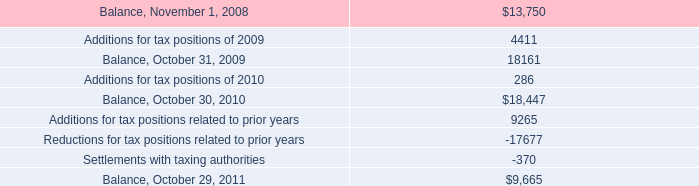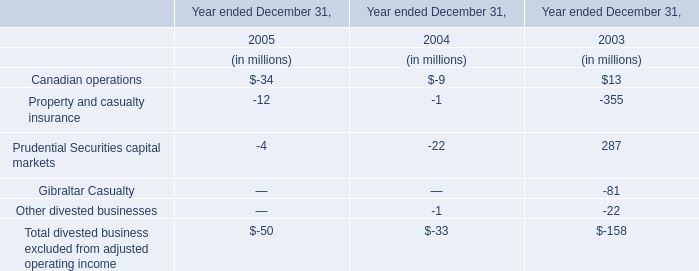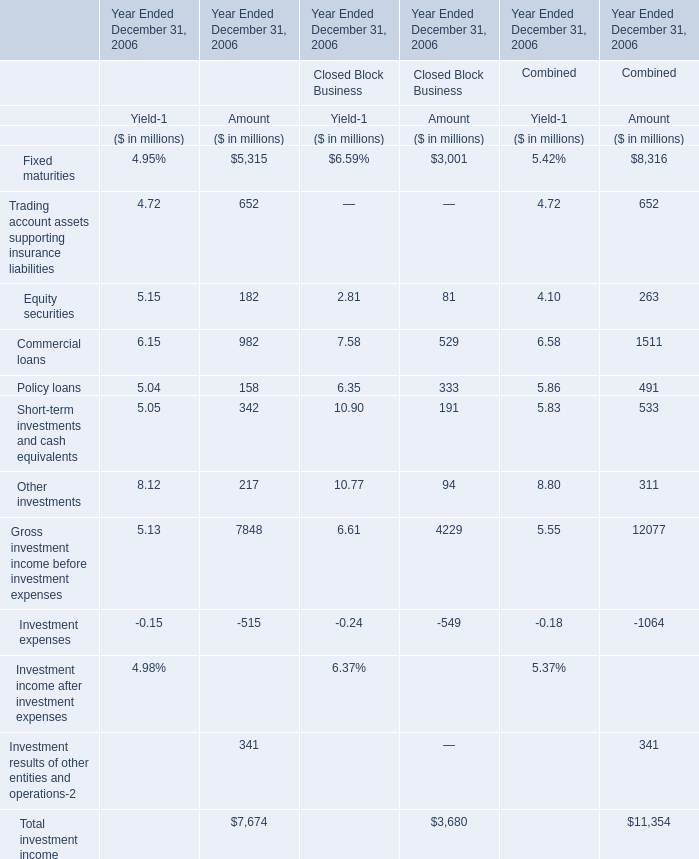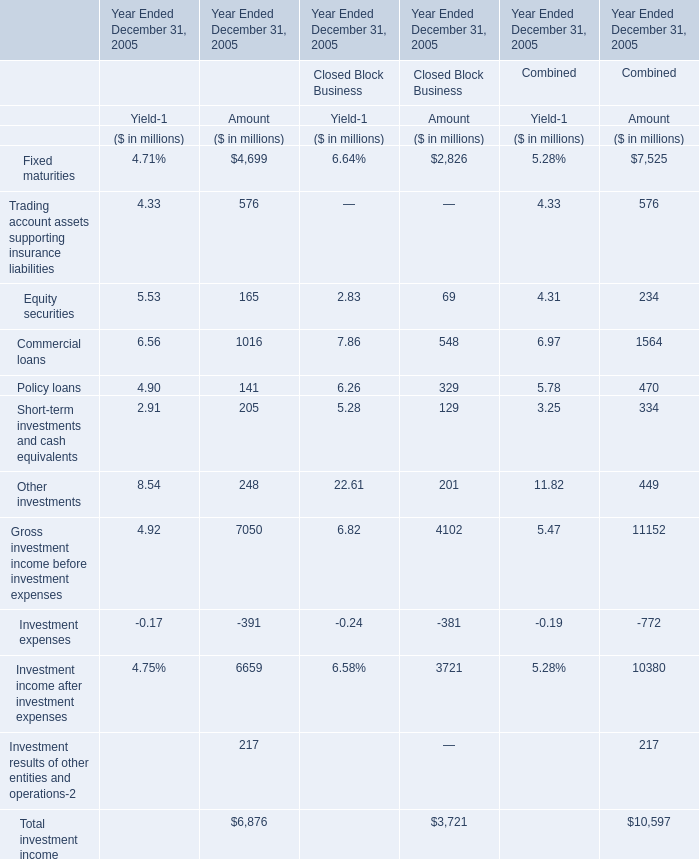What was the sum of elements without those elements smaller than 900 for Amount of Financial Services Businesses? (in million) 
Computations: (5315 + 982)
Answer: 6297.0. 